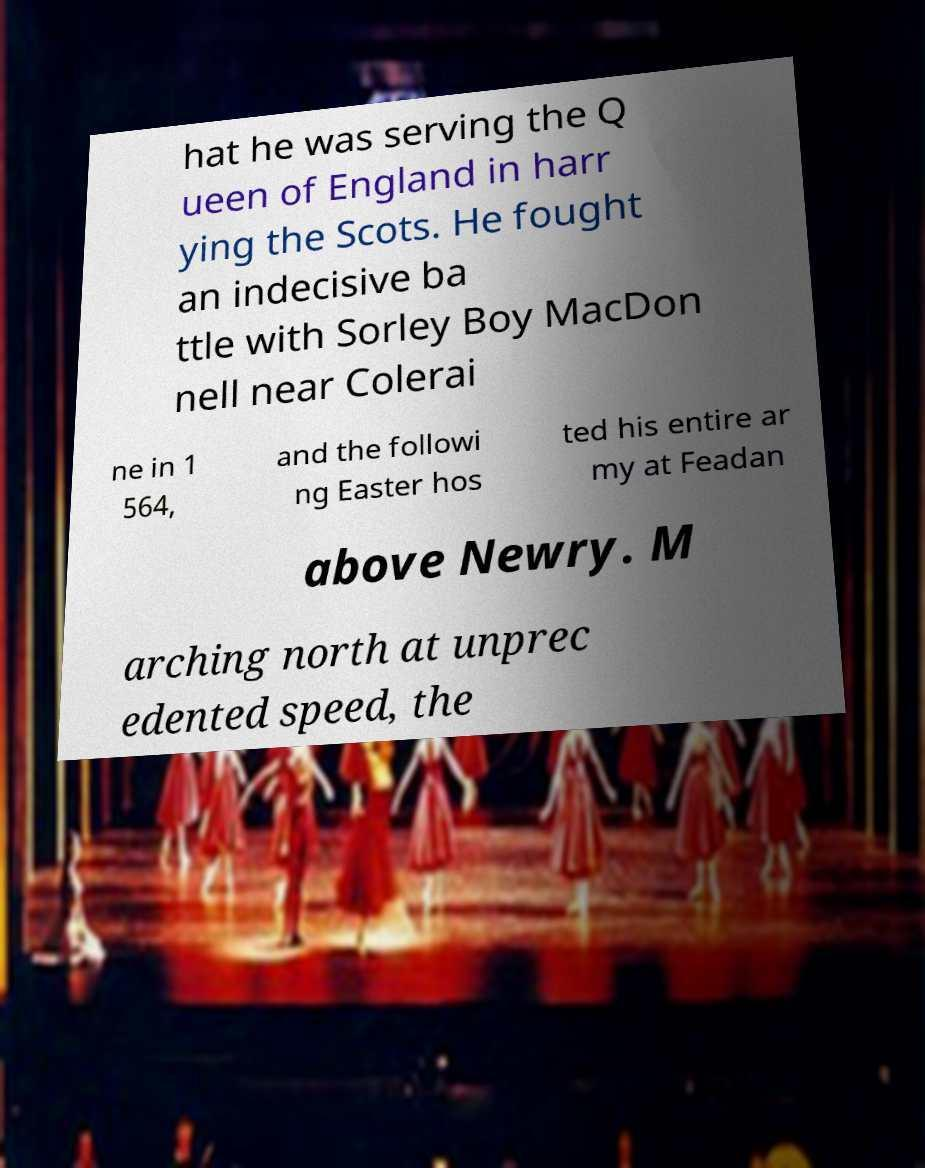What messages or text are displayed in this image? I need them in a readable, typed format. hat he was serving the Q ueen of England in harr ying the Scots. He fought an indecisive ba ttle with Sorley Boy MacDon nell near Colerai ne in 1 564, and the followi ng Easter hos ted his entire ar my at Feadan above Newry. M arching north at unprec edented speed, the 